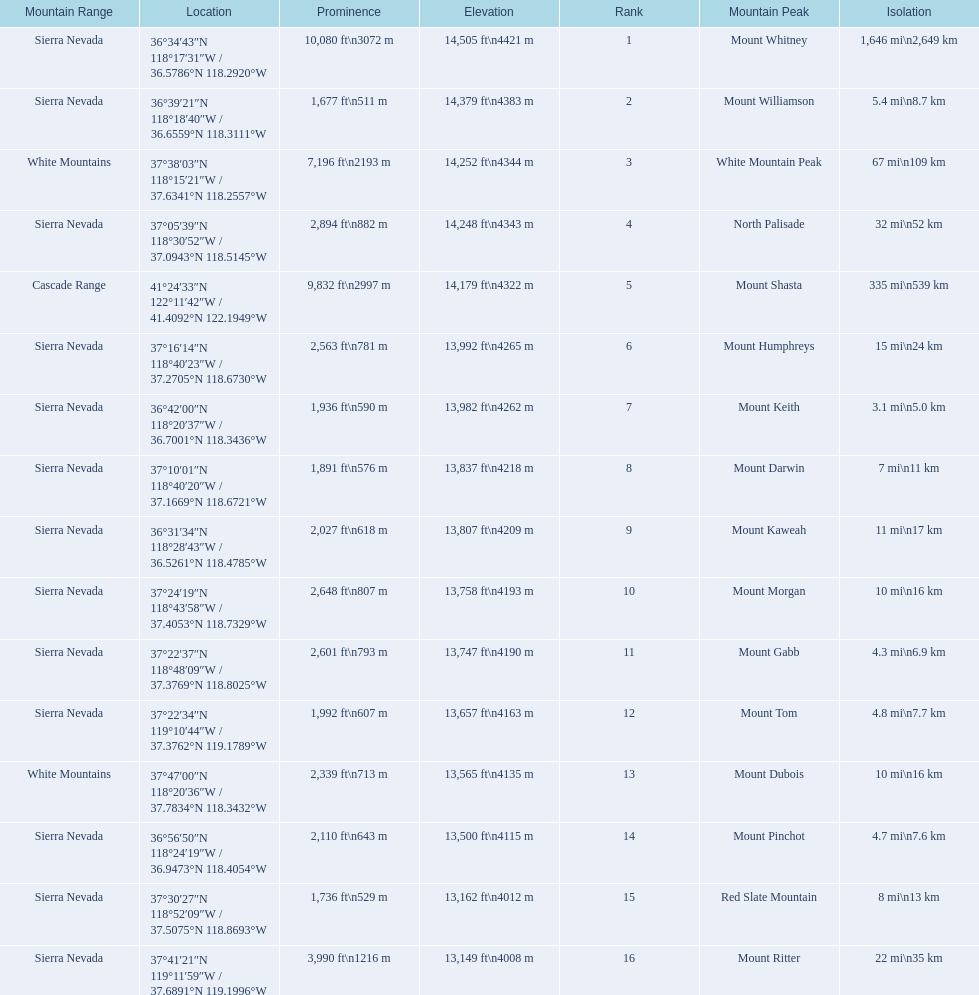What are the heights of the peaks? 14,505 ft\n4421 m, 14,379 ft\n4383 m, 14,252 ft\n4344 m, 14,248 ft\n4343 m, 14,179 ft\n4322 m, 13,992 ft\n4265 m, 13,982 ft\n4262 m, 13,837 ft\n4218 m, 13,807 ft\n4209 m, 13,758 ft\n4193 m, 13,747 ft\n4190 m, 13,657 ft\n4163 m, 13,565 ft\n4135 m, 13,500 ft\n4115 m, 13,162 ft\n4012 m, 13,149 ft\n4008 m. Which of these heights is tallest? 14,505 ft\n4421 m. What peak is 14,505 feet? Mount Whitney. 